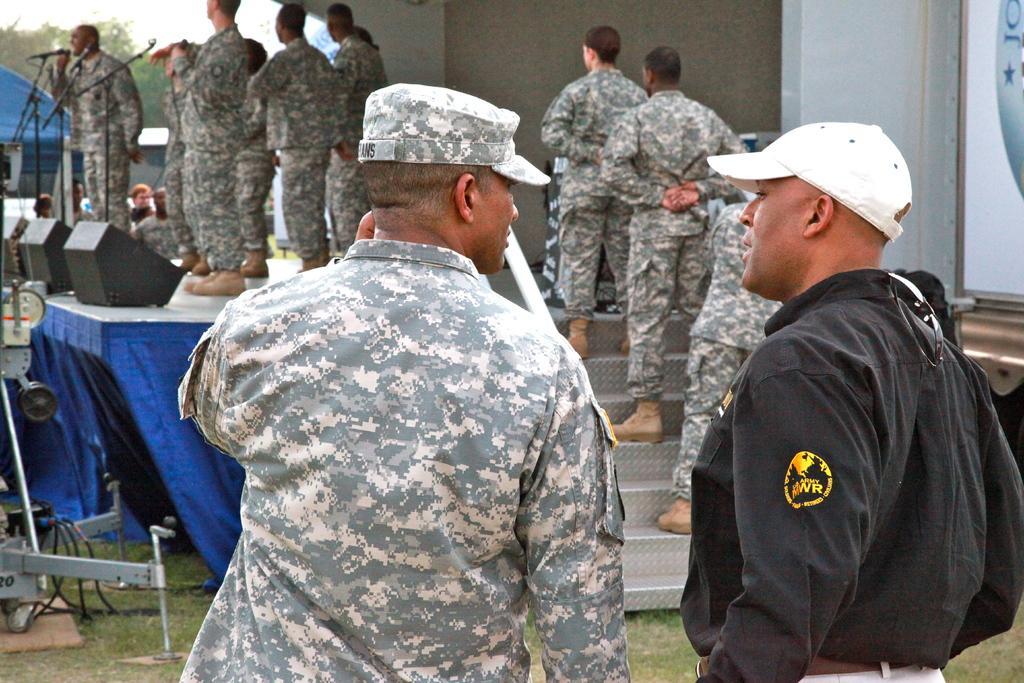Describe this image in one or two sentences. As we can see in the image there are buildings, stairs and group of people. Few of them are wearing army dresses and there is stage. On the left side there are mics. 